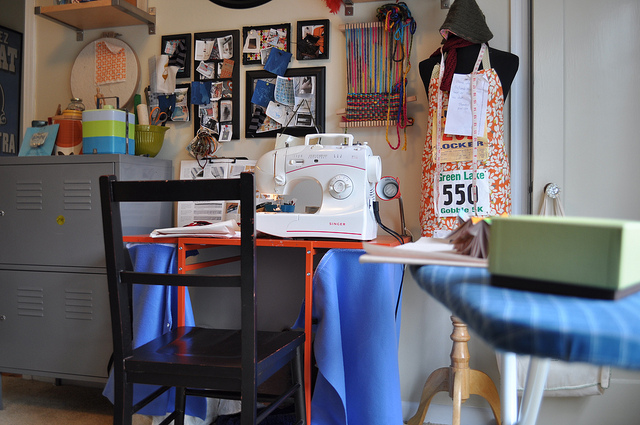Please extract the text content from this image. OCKER Green 550 